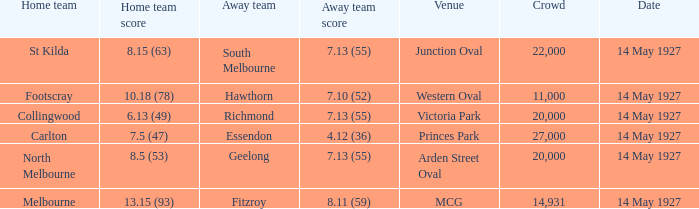Which away team had a score of 4.12 (36)? Essendon. 